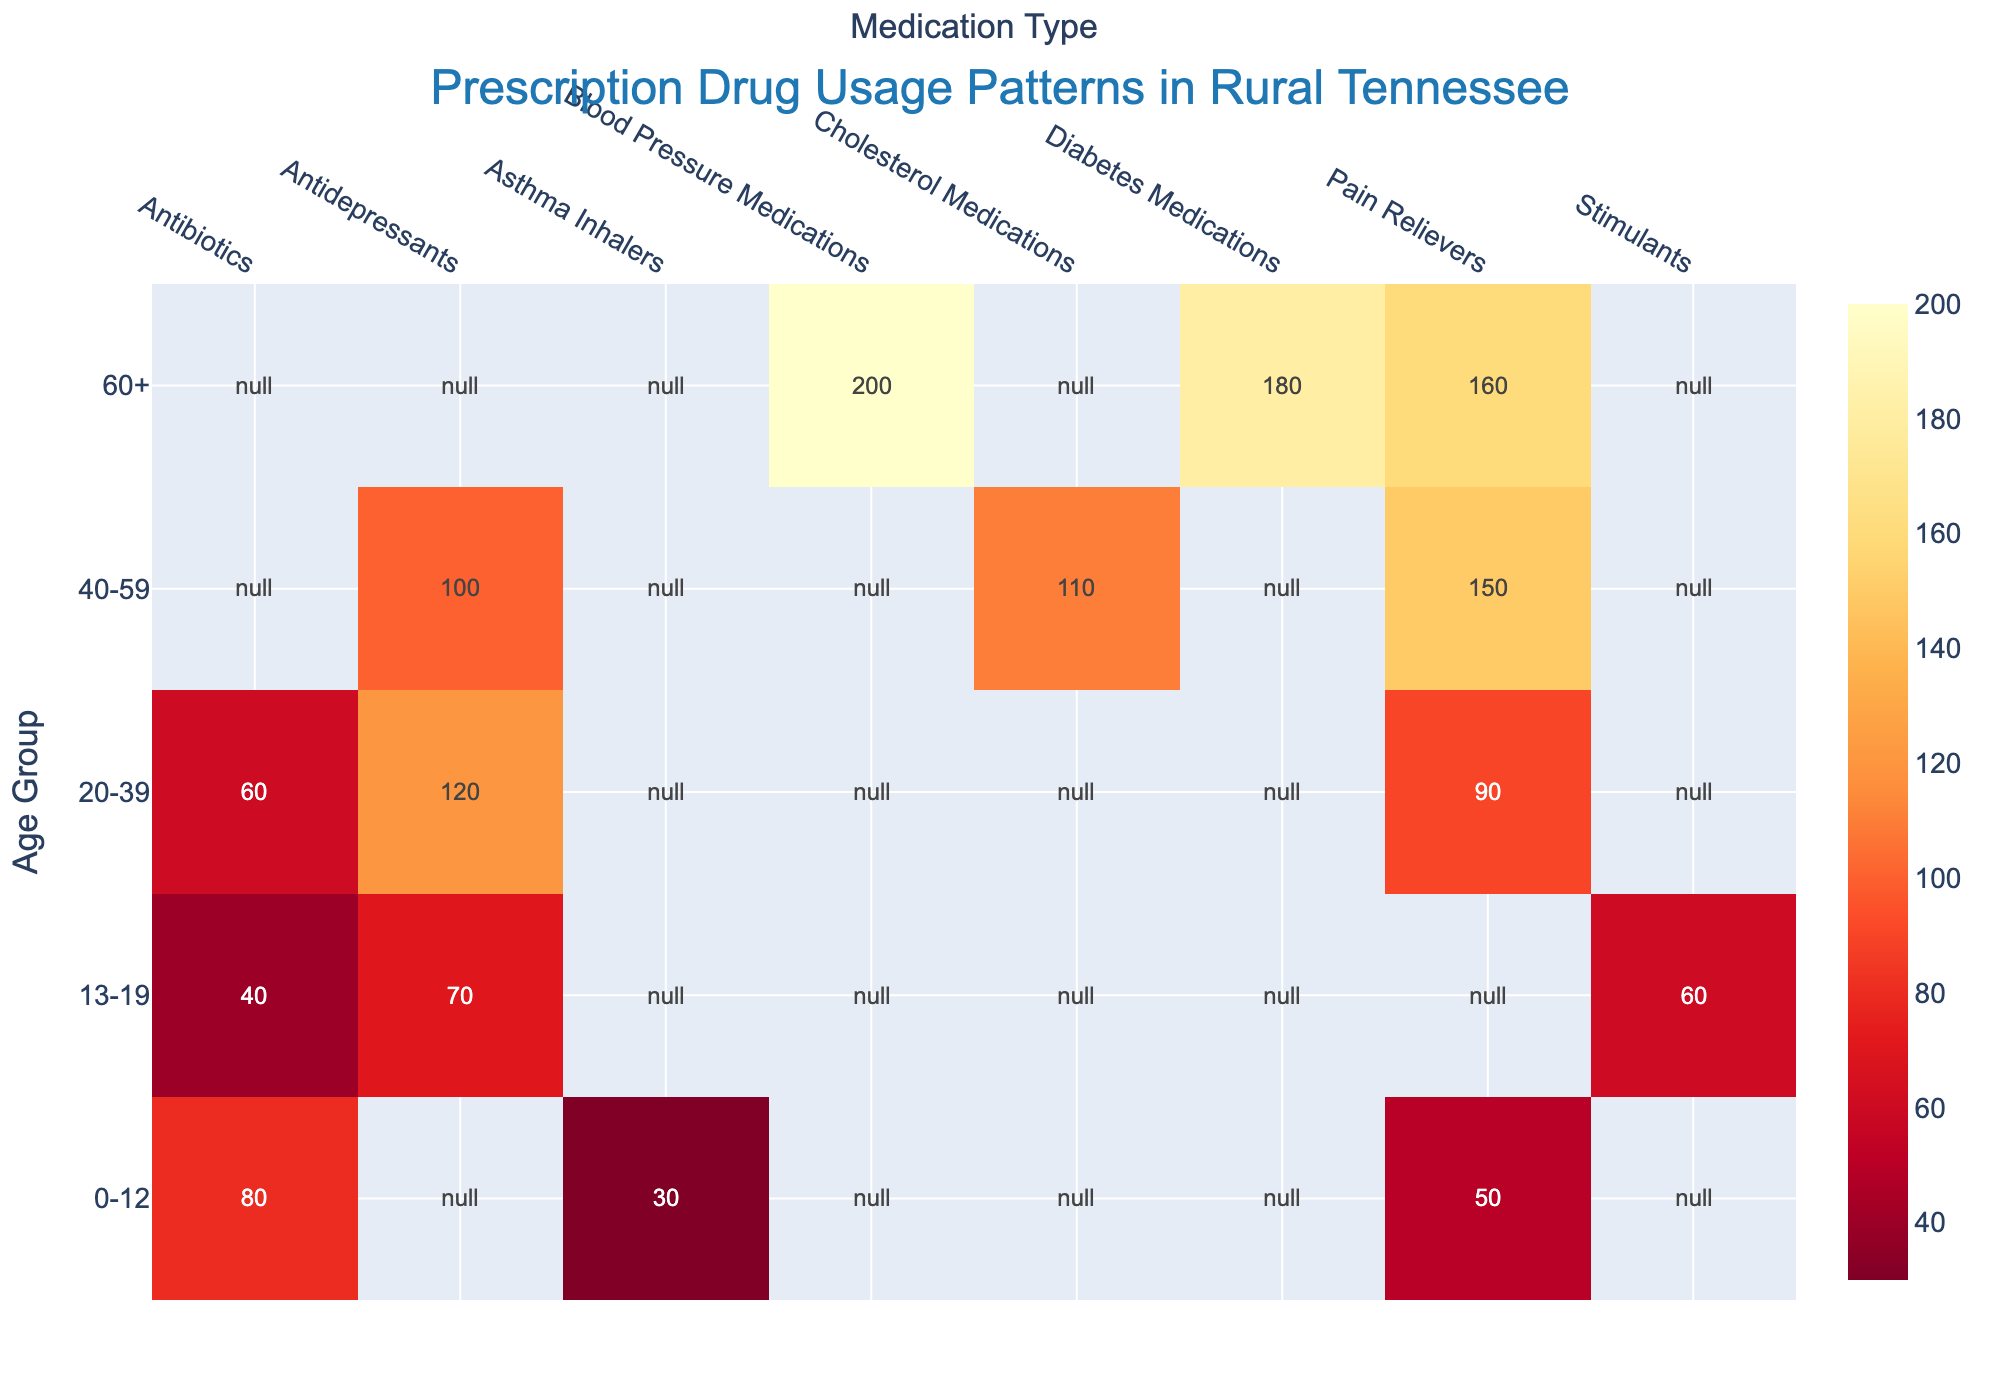What is the highest number of prescriptions for the age group 60+? Look at the row corresponding to the 60+ age group and identify the maximum value. The highest number is under Blood Pressure Medications with 200.
Answer: 200 How many prescriptions for Antidepressants were given to the 20-39 age group? Locate the intersection of the 20-39 age row and the Antidepressants column. The value there is 120.
Answer: 120 Which age group has the highest number of Pain Relievers prescriptions? Compare the values for Pain Relievers across all age groups to find the maximum. The 40-59 age group has 150 Pain Relievers prescriptions, which is the highest.
Answer: 40-59 What is the total number of prescriptions for Antibiotics? Sum the values in the Antibiotics column: 80 (0-12) + 40 (13-19) + 60 (20-39) = 180.
Answer: 180 Between the 0-12 and 13-19 age groups, which has a higher total number of prescriptions for all medication types combined? Add the number of prescriptions for each medication in the specified age groups. For the 0-12 age group: 80 (Antibiotics) + 50 (Pain Relievers) + 30 (Asthma Inhalers) = 160. For the 13-19 age group: 70 (Antidepressants) + 60 (Stimulants) + 40 (Antibiotics) = 170. The 13-19 age group has a higher total.
Answer: 13-19 What is the most prescribed type of medication across all age groups? Identify the medication type with the highest total sum across all age groups by summing each column. Pain Relievers have the highest total: 50 (0-12) + 150 (40-59) + 160 (60+) = 360.
Answer: Pain Relievers Which two types of medications have the closest number of prescriptions for the 13-19 age group? Compare the values within the 13-19 age group row to see which two are closest in value. Antidepressants (70) and Stimulants (60) are 10 units apart and are the closest.
Answer: Antidepressants and Stimulants Is the number of prescriptions for Diabetes Medications in the 60+ age group less than or greater than the number of Pain Relievers prescriptions in the same age group? Compare the two values within the 60+ age group row. Diabetes Medications have 180 prescriptions, while Pain Relievers have 160. Thus, Diabetes Medications are greater.
Answer: Greater What is the sum of prescriptions for Cholesterol Medications in the 40-59 age group and Blood Pressure Medications in the 60+ age group? Add the values for the specified cells: 110 (Cholesterol Medications) + 200 (Blood Pressure Medications) = 310.
Answer: 310 